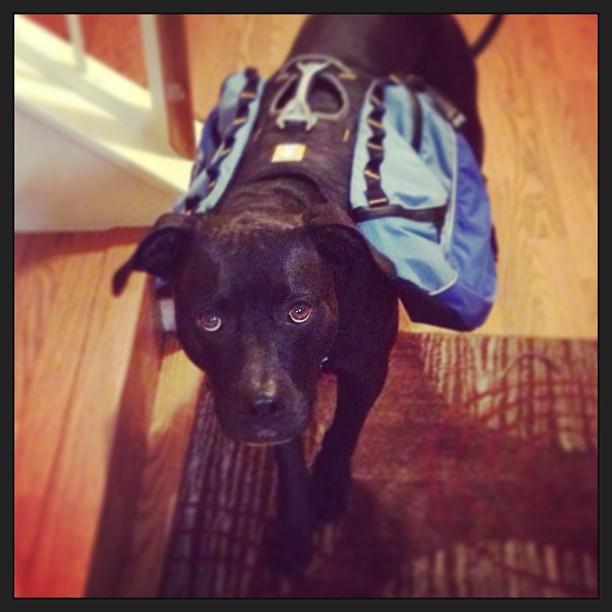How many vases in the picture?
Give a very brief answer. 0. 